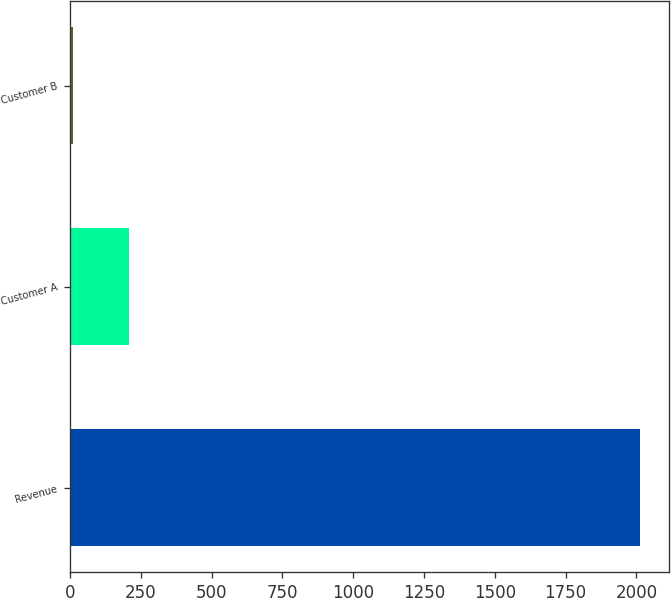<chart> <loc_0><loc_0><loc_500><loc_500><bar_chart><fcel>Revenue<fcel>Customer A<fcel>Customer B<nl><fcel>2013<fcel>209.4<fcel>9<nl></chart> 